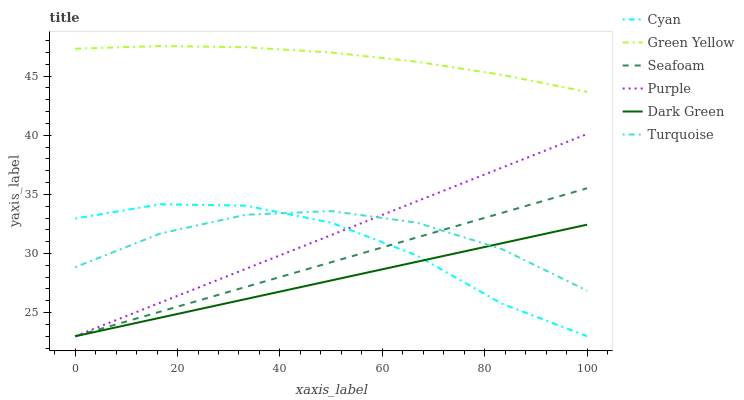Does Dark Green have the minimum area under the curve?
Answer yes or no. Yes. Does Green Yellow have the maximum area under the curve?
Answer yes or no. Yes. Does Purple have the minimum area under the curve?
Answer yes or no. No. Does Purple have the maximum area under the curve?
Answer yes or no. No. Is Purple the smoothest?
Answer yes or no. Yes. Is Cyan the roughest?
Answer yes or no. Yes. Is Seafoam the smoothest?
Answer yes or no. No. Is Seafoam the roughest?
Answer yes or no. No. Does Green Yellow have the lowest value?
Answer yes or no. No. Does Purple have the highest value?
Answer yes or no. No. Is Turquoise less than Green Yellow?
Answer yes or no. Yes. Is Green Yellow greater than Cyan?
Answer yes or no. Yes. Does Turquoise intersect Green Yellow?
Answer yes or no. No. 